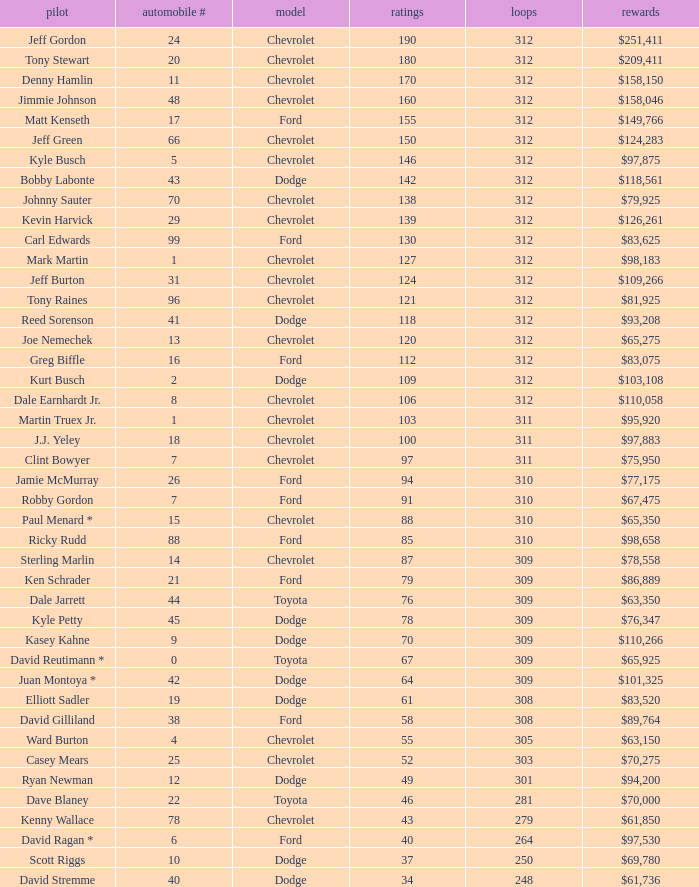What is the lowest number of laps for kyle petty with under 118 points? 309.0. 